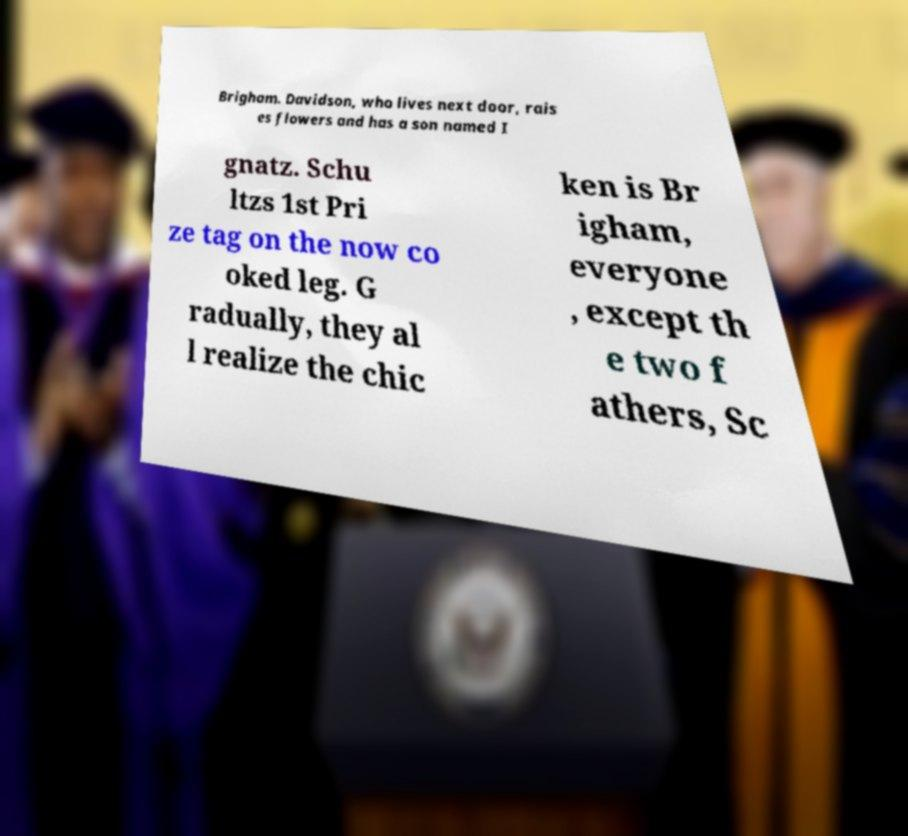Could you assist in decoding the text presented in this image and type it out clearly? Brigham. Davidson, who lives next door, rais es flowers and has a son named I gnatz. Schu ltzs 1st Pri ze tag on the now co oked leg. G radually, they al l realize the chic ken is Br igham, everyone , except th e two f athers, Sc 